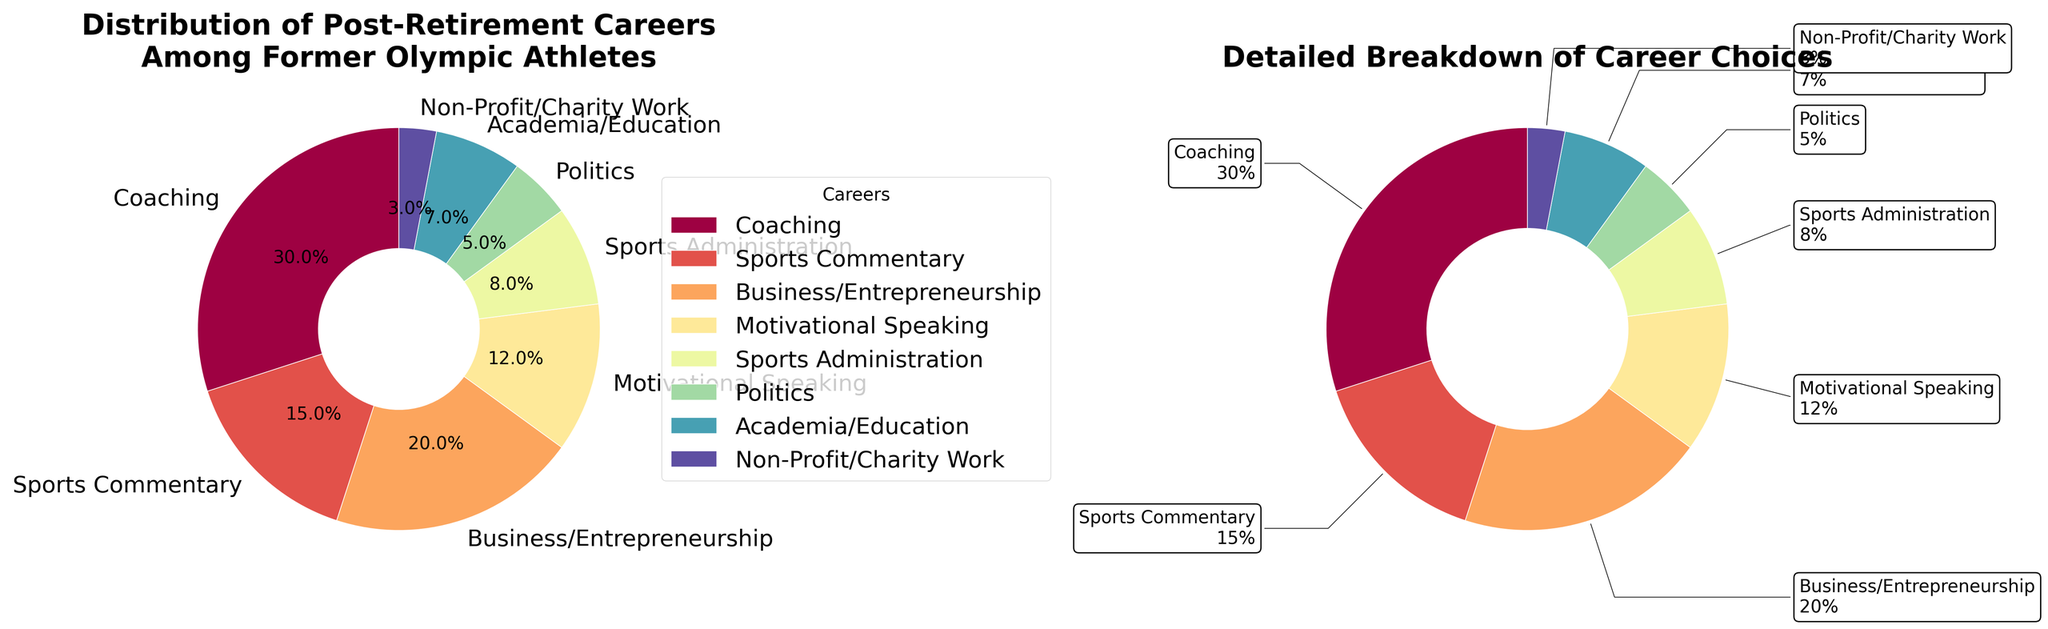What is the percentage of former Olympic athletes who pursue coaching? The chart shows that the "Coaching" segment is labeled with 30%, indicating that 30% of former Olympic athletes choose coaching as their post-retirement career.
Answer: 30% What’s the combined percentage of athletes who go into politics and non-profit/charity work? By looking at the percentages for each career choice, we can see that politics is 5% and non-profit/charity work is 3%. Adding these together: 5% + 3% = 8%.
Answer: 8% Which career has a higher percentage: Business/Entrepreneurship or Academia/Education? The pie chart shows that Business/Entrepreneurship has a percentage of 20%, while Academia/Education has a percentage of 7%. Comparing these values, Business/Entrepreneurship has a higher percentage.
Answer: Business/Entrepreneurship What is the total percentage of athletes involved in sports-related careers (Coaching, Sports Commentary, Sports Administration)? Summing up the percentages for Coaching (30%), Sports Commentary (15%), and Sports Administration (8%): 30% + 15% + 8% = 53%.
Answer: 53% Which segment is the smallest and what is its percentage? The chart segments are labeled with their respective percentages. The smallest segment is Non-Profit/Charity Work with 3%.
Answer: Non-Profit/Charity Work, 3% Comparing 'Motivational Speaking' and 'Sports Commentary', which has a higher representation and by how much? The pie chart shows Motivational Speaking with 12% and Sports Commentary with 15%. The difference is 15% - 12% = 3%.
Answer: Sports Commentary by 3% What is the visual appearance difference between the two subplots? The left subplot is a conventional pie chart without a center cutout, while the right subplot is a donut chart with a center cutout and annotated labels outside the chart.
Answer: One is a pie chart, and the other is a donut chart How many career choices are represented in the pie charts? By counting the segments in the pie charts, we observe that there are eight distinct career choices.
Answer: 8 Which career choice accounts for approximately one-fifth of the post-retirement options? The chart shows that Business/Entrepreneurship has a percentage of 20%, which is roughly one-fifth of the total distribution.
Answer: Business/Entrepreneurship What fraction of athletes choose professions in education-related fields? Adding the percentages of Academia/Education (7%) and Motivational Speaking (12%) gives us 7% + 12% = 19%. Since the total is 100%, the fraction is 19/100 or approximately 1/5.
Answer: 1/5 